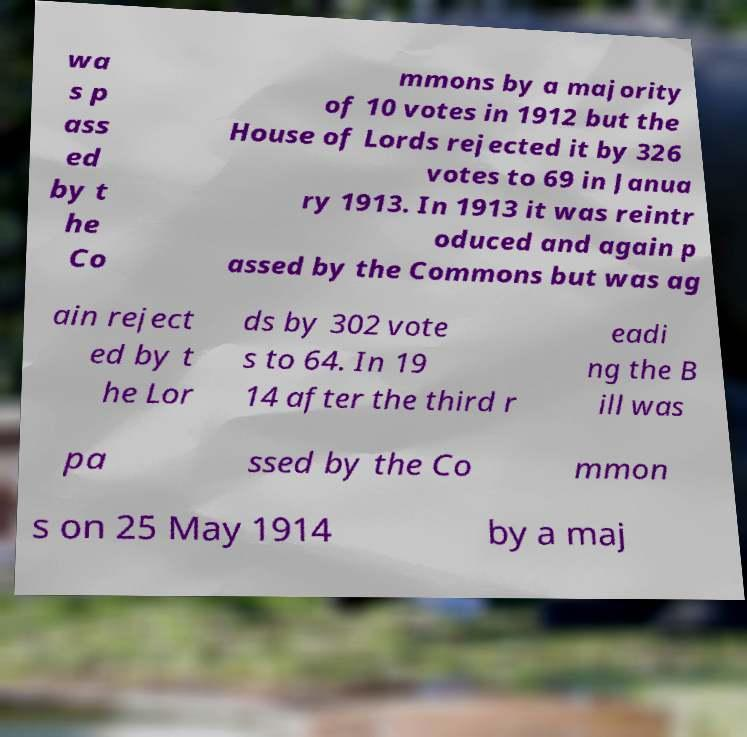What messages or text are displayed in this image? I need them in a readable, typed format. wa s p ass ed by t he Co mmons by a majority of 10 votes in 1912 but the House of Lords rejected it by 326 votes to 69 in Janua ry 1913. In 1913 it was reintr oduced and again p assed by the Commons but was ag ain reject ed by t he Lor ds by 302 vote s to 64. In 19 14 after the third r eadi ng the B ill was pa ssed by the Co mmon s on 25 May 1914 by a maj 